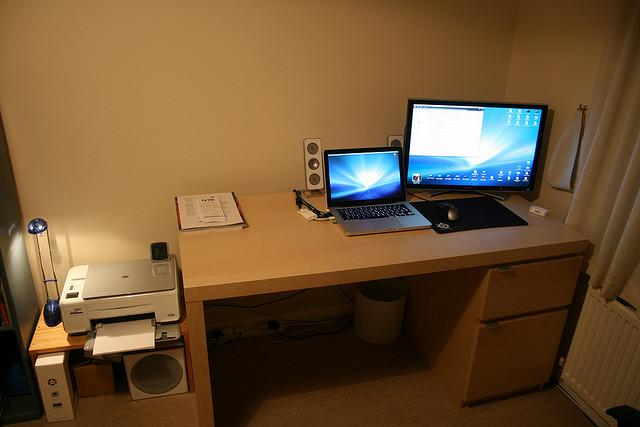What is this desk made of?

Choices:
A) laminated wood
B) oak
C) pine
D) plywood laminated wood 